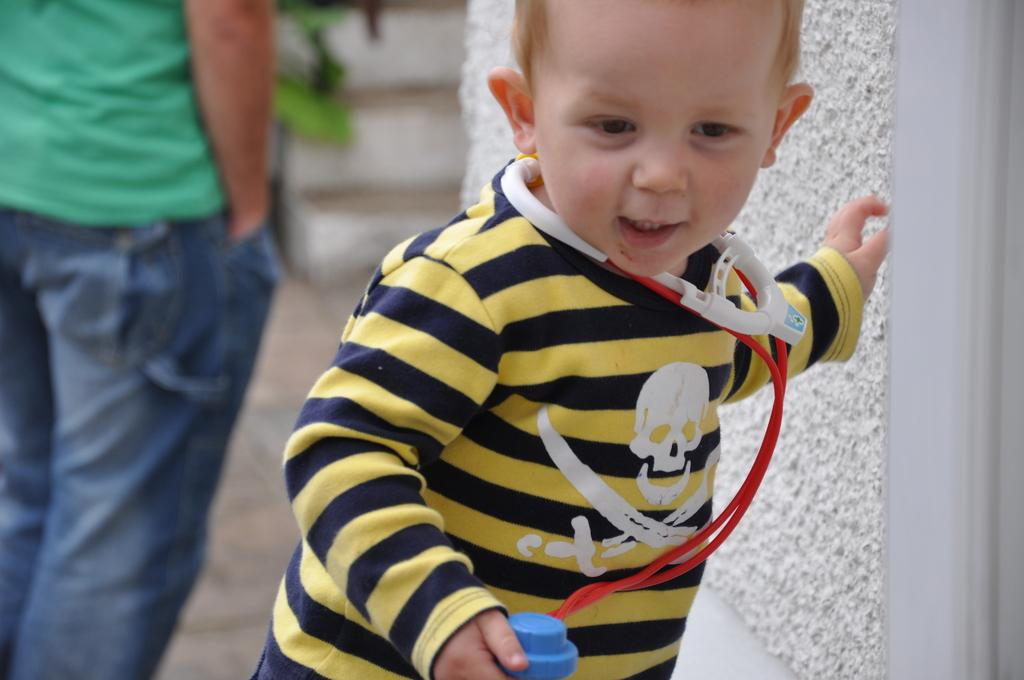How many people are on the floor in the image? There are two persons on the floor in the image. What can be seen in the background of the image? There is a wall, a houseplant, and a bench in the background of the image. What might suggest that the image was taken during the day? The likely presence of natural light and the absence of artificial lighting might suggest that the image was taken during the day. What type of tree can be seen growing through the truck in the image? There is no tree or truck present in the image. 